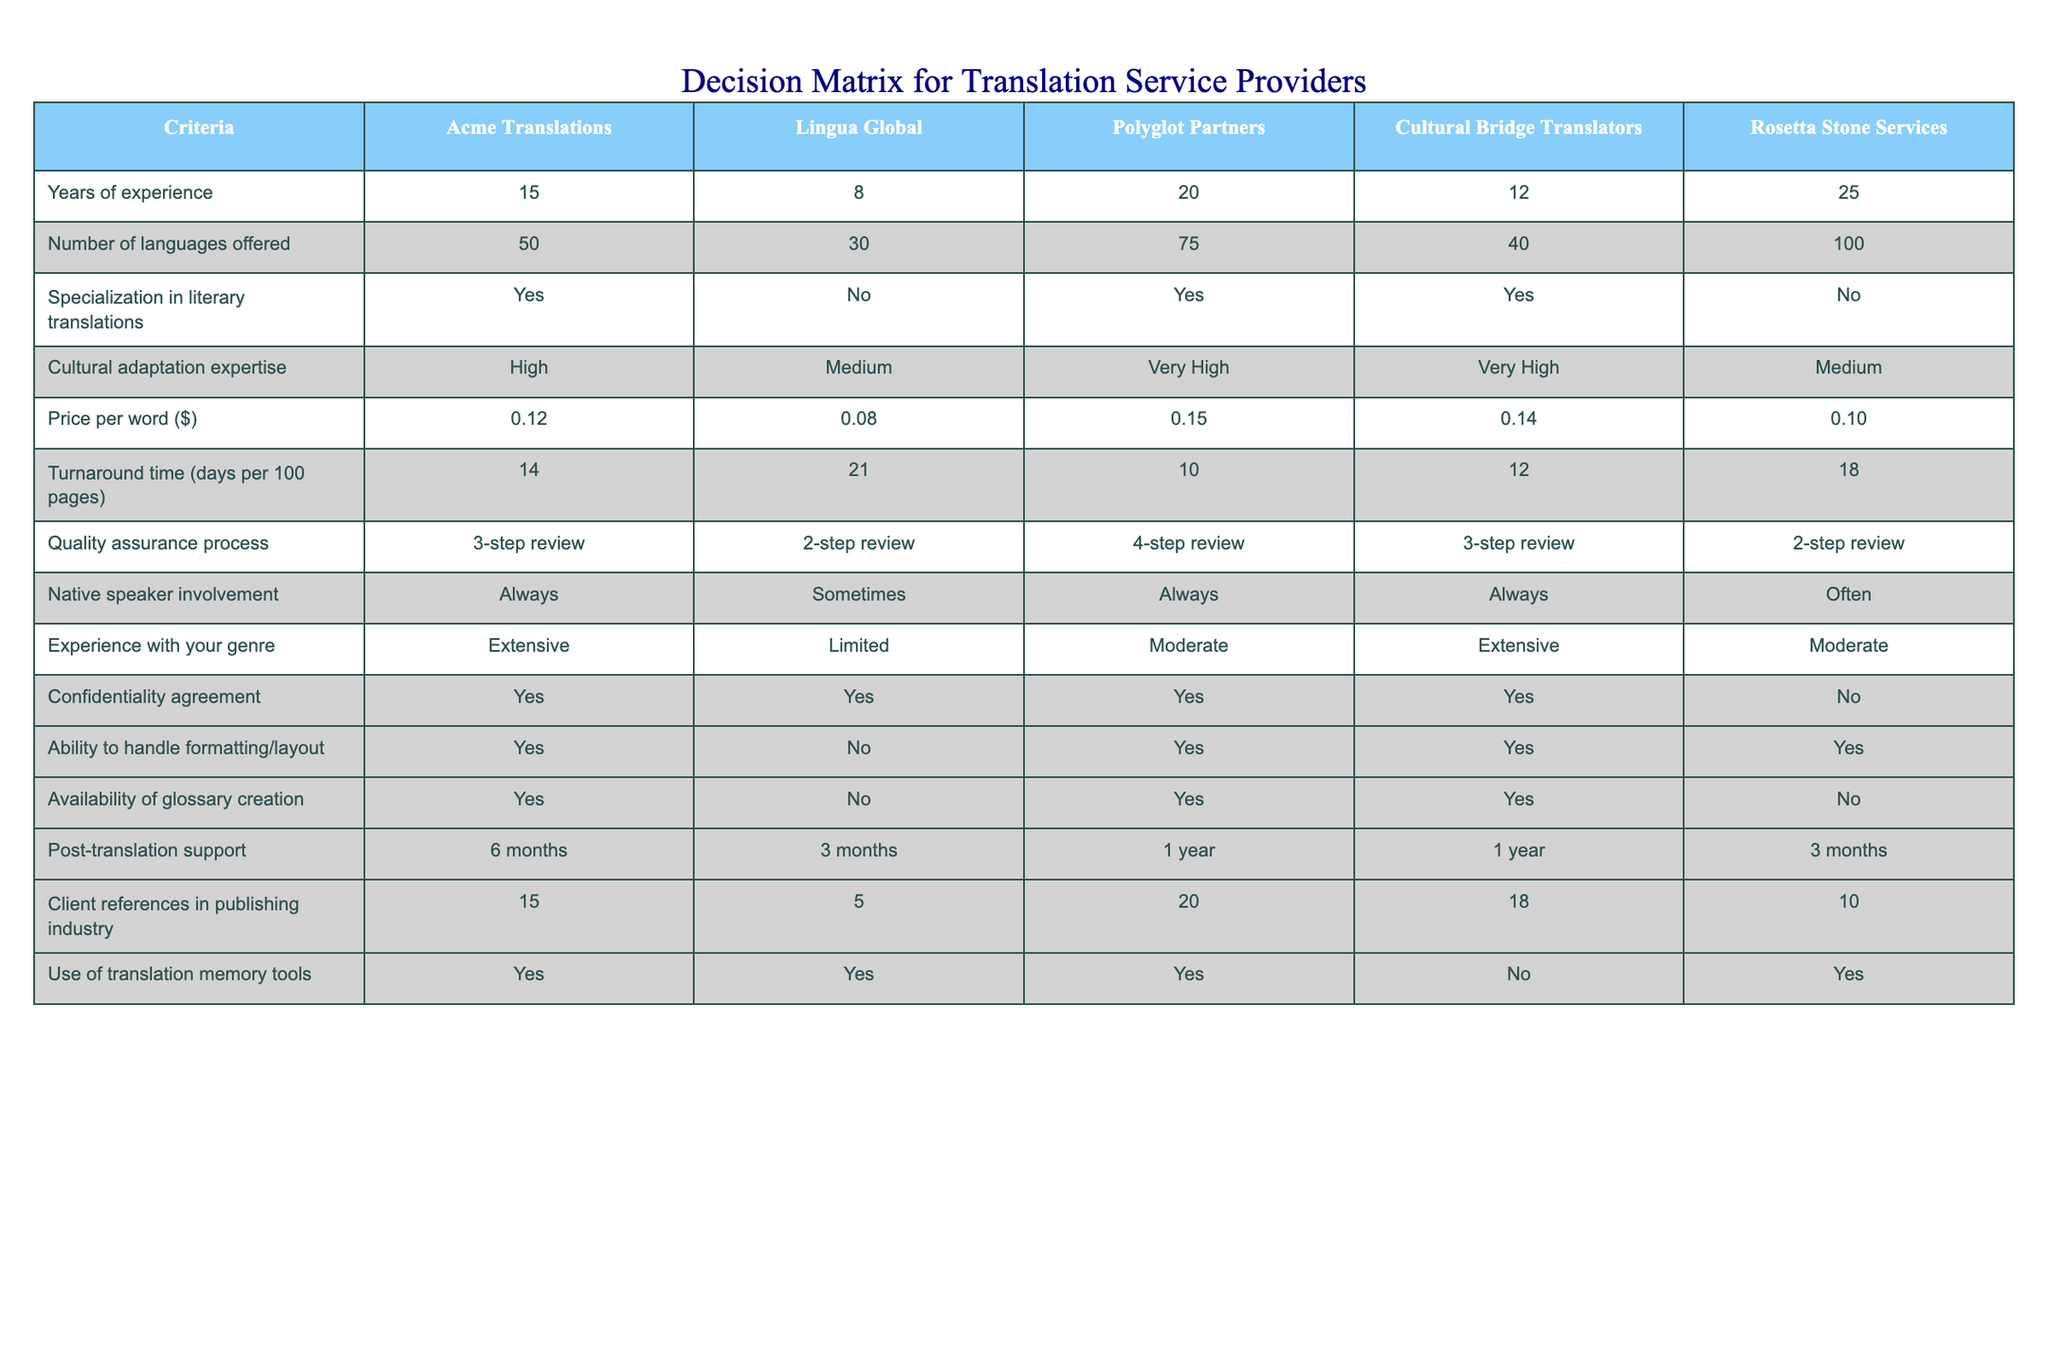What is the price per word for Lingua Global? The price per word for Lingua Global is listed in the table under the "Price per word ($)" column. Looking at the row for Lingua Global, the value is 0.08.
Answer: 0.08 Which translation service provider has the highest number of languages offered? By examining the "Number of languages offered" column, I can identify that Rosetta Stone Services, with 100 languages, has the highest count compared to all other providers in the table.
Answer: Rosetta Stone Services Does Acme Translations specialize in literary translations? The relevant column for this inquiry is "Specialization in literary translations." The row for Acme Translations indicates that it specializes in literary translations, marking it as "Yes."
Answer: Yes What is the average turnaround time for the first three service providers? I add the turnaround times for Acme Translations (14), Lingua Global (21), and Polyglot Partners (10) together: 14 + 21 + 10 = 45. Then, I divide by the number of providers, which is 3, yielding an average of 45 / 3 = 15.
Answer: 15 How many service providers have very high cultural adaptation expertise? I will check the "Cultural adaptation expertise" column for the classification "Very High." Both Polyglot Partners and Cultural Bridge Translators meet this criterion. Therefore, there are 2 service providers that qualify.
Answer: 2 Which translation service provider offers post-translation support for the longest duration? The table indicates the post-translation support duration for each provider. Polyglot Partners and Cultural Bridge Translators both provide post-translation support for 1 year, which is the longest duration seen in the table.
Answer: Polyglot Partners and Cultural Bridge Translators What is the difference in client references between Polyglot Partners and Rosetta Stone Services? To find the difference, I subtract the number of client references for Rosetta Stone Services (10) from that of Polyglot Partners (20): 20 - 10 = 10.
Answer: 10 Is there a service provider that does not offer a confidentiality agreement? Referring to the "Confidentiality agreement" column, I see that Rosetta Stone Services indicates "No" for the confidentiality agreement, confirming that this provider does not offer one.
Answer: Yes What is the native speaker involvement status for Polyglot Partners? In the "Native speaker involvement" column, Polyglot Partners is marked as "Always," indicating that they involve native speakers in their translation process.
Answer: Always 